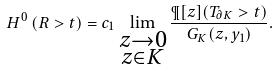<formula> <loc_0><loc_0><loc_500><loc_500>H ^ { 0 } \left ( R > t \right ) = c _ { 1 } \lim _ { \substack { z \to 0 \\ z \in K } } \frac { \P [ z ] ( T _ { \partial K } > t ) } { G _ { K } ( z , y _ { 1 } ) } .</formula> 